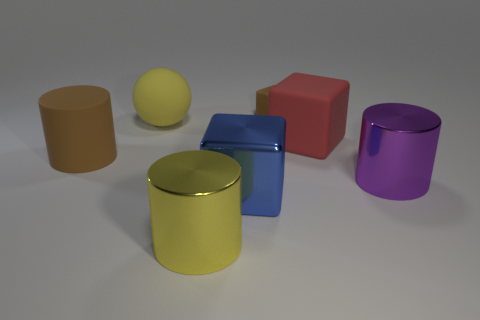Subtract all big blue metallic blocks. How many blocks are left? 2 Subtract 1 cylinders. How many cylinders are left? 2 Add 2 big purple things. How many objects exist? 9 Subtract all cylinders. How many objects are left? 4 Add 4 purple cylinders. How many purple cylinders are left? 5 Add 7 rubber blocks. How many rubber blocks exist? 9 Subtract 0 purple blocks. How many objects are left? 7 Subtract all yellow balls. Subtract all purple metal cylinders. How many objects are left? 5 